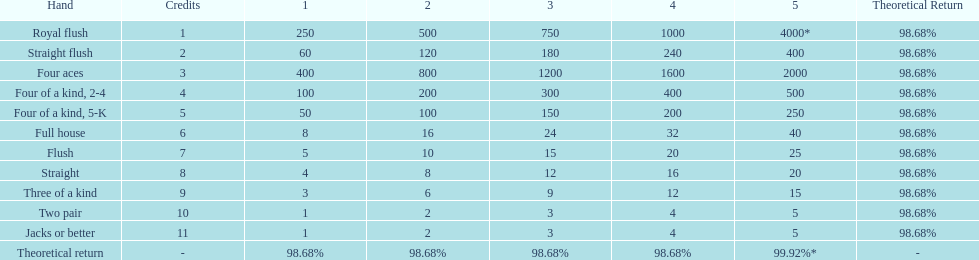Which hand is lower than straight flush? Four aces. Which hand is lower than four aces? Four of a kind, 2-4. Which hand is higher out of straight and flush? Flush. 